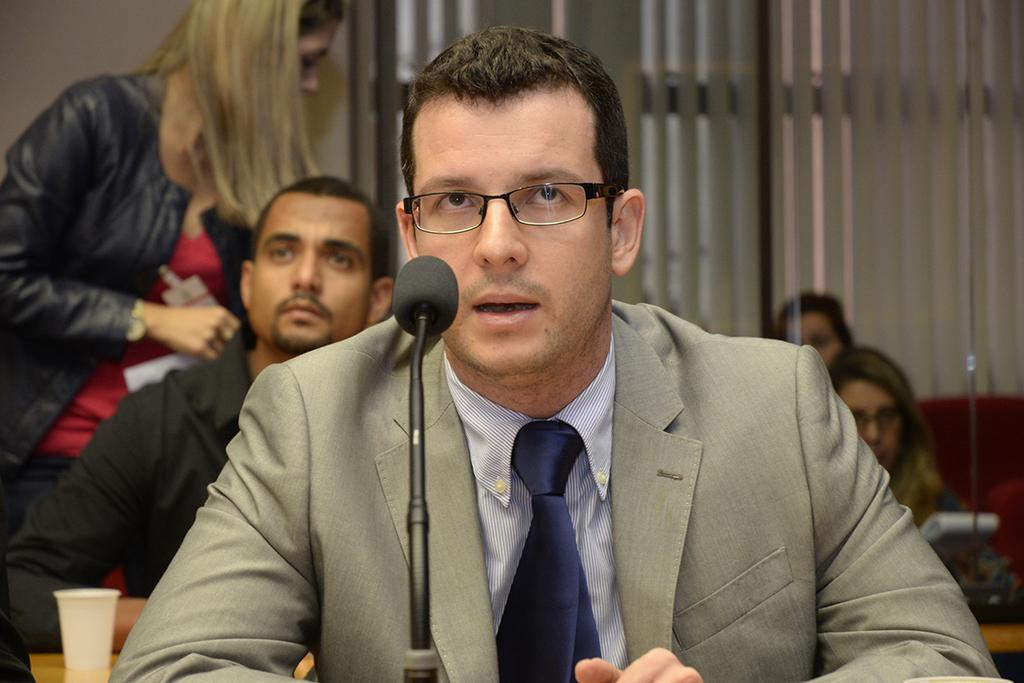What is the man in the image doing? The man is speaking into a microphone. What is the man wearing in the image? The man is wearing a shirt, coat, and tie. Who else is present in the image? There is a woman in the image. What is the woman wearing in the image? The woman is wearing a black coat and a red top. What type of bells can be heard ringing in the image? There are no bells present in the image, and therefore no sound can be heard. 